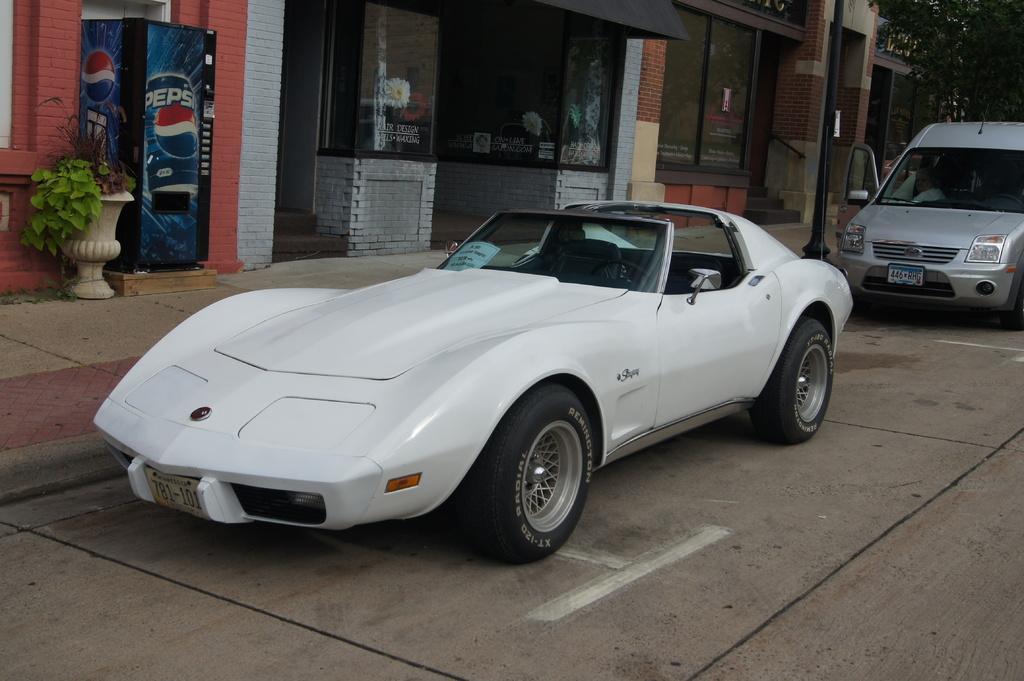Describe this image in one or two sentences. In this image we can see vehicles on the road, beside that there are buildings, refrigerator, flower pot, trees and a pole. 